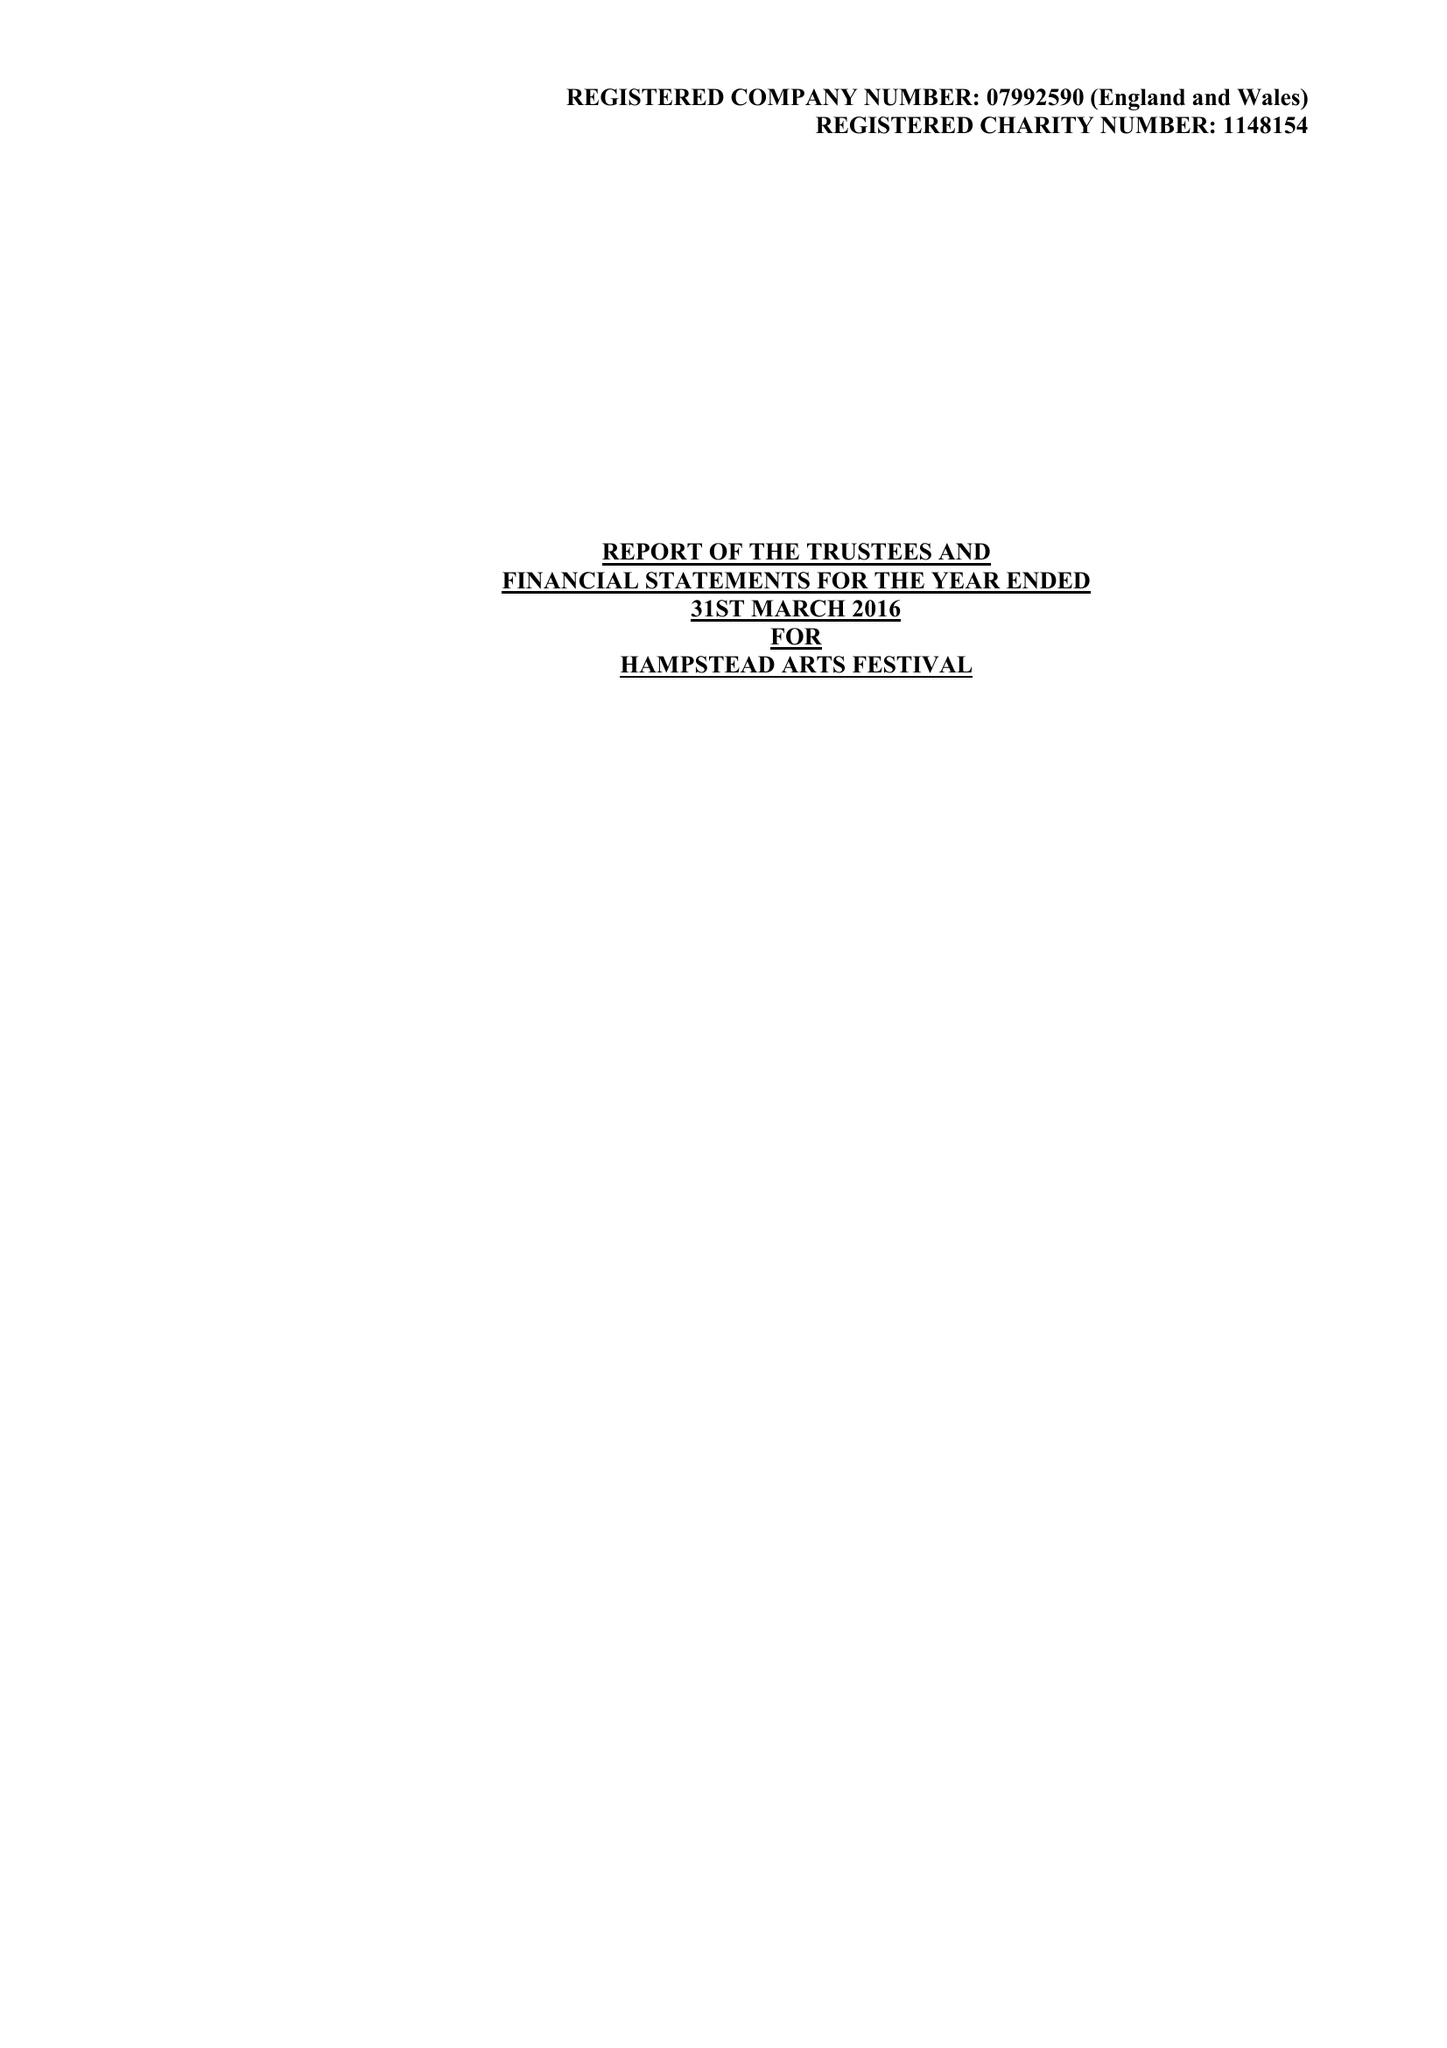What is the value for the spending_annually_in_british_pounds?
Answer the question using a single word or phrase. 51907.00 